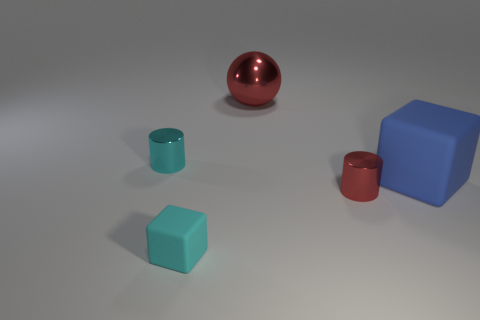What number of tiny cyan cylinders are behind the large blue thing that is in front of the shiny ball?
Give a very brief answer. 1. How many other things are the same size as the cyan matte thing?
Your response must be concise. 2. There is a object that is the same color as the tiny rubber block; what is its size?
Ensure brevity in your answer.  Small. There is a rubber thing that is to the right of the large red ball; does it have the same shape as the tiny cyan matte thing?
Ensure brevity in your answer.  Yes. What is the material of the cube to the left of the blue rubber object?
Your answer should be very brief. Rubber. The tiny metallic object that is the same color as the metallic ball is what shape?
Your answer should be compact. Cylinder. Is there a cyan object made of the same material as the blue cube?
Ensure brevity in your answer.  Yes. How big is the cyan metallic cylinder?
Give a very brief answer. Small. What number of blue things are either large matte blocks or cubes?
Ensure brevity in your answer.  1. How many other small red shiny things have the same shape as the tiny red metallic object?
Offer a very short reply. 0. 